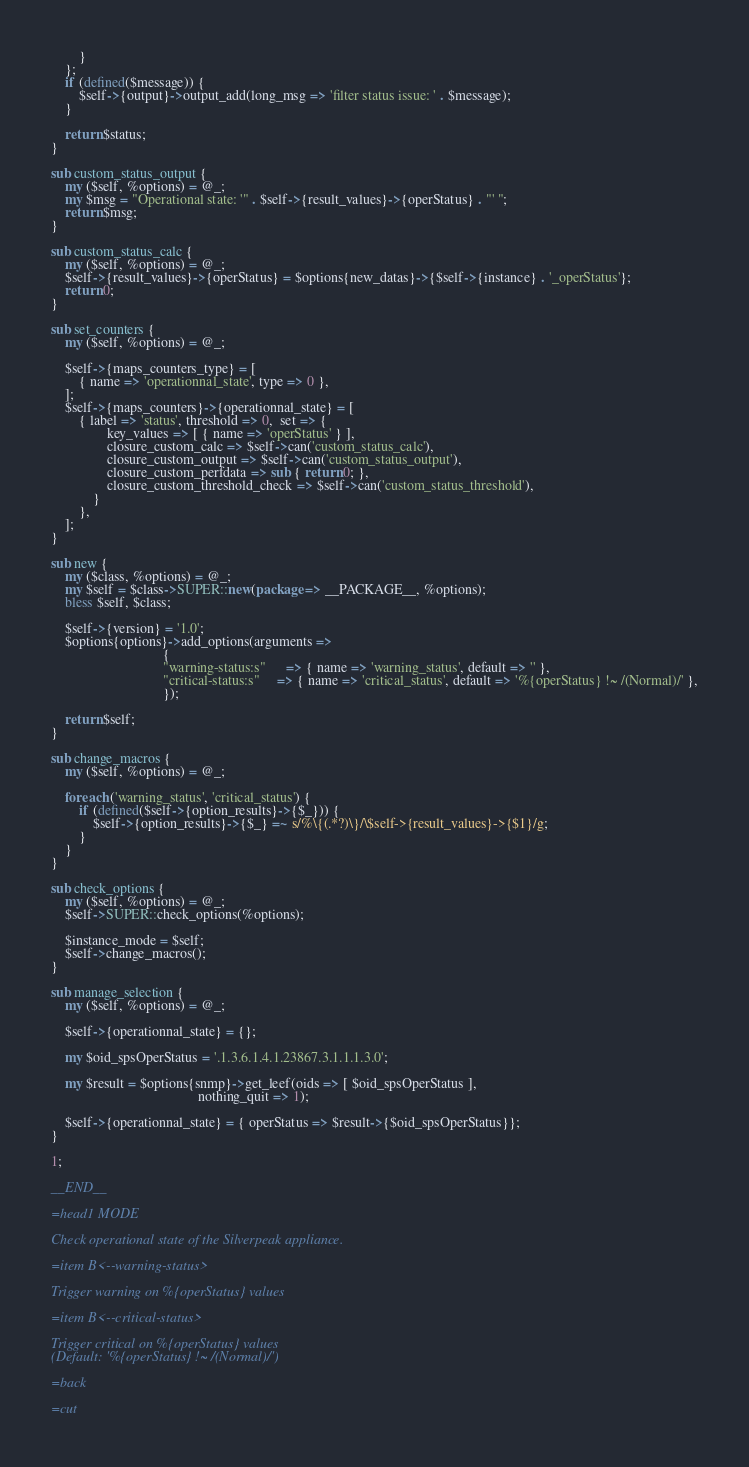<code> <loc_0><loc_0><loc_500><loc_500><_Perl_>        }
    };
    if (defined($message)) {
        $self->{output}->output_add(long_msg => 'filter status issue: ' . $message);
    }

    return $status;
}

sub custom_status_output {
    my ($self, %options) = @_;
    my $msg = "Operational state: '" . $self->{result_values}->{operStatus} . "' ";
    return $msg;
}

sub custom_status_calc {
    my ($self, %options) = @_;
    $self->{result_values}->{operStatus} = $options{new_datas}->{$self->{instance} . '_operStatus'};
    return 0;
}

sub set_counters {
    my ($self, %options) = @_;

    $self->{maps_counters_type} = [
        { name => 'operationnal_state', type => 0 },
    ];
    $self->{maps_counters}->{operationnal_state} = [
        { label => 'status', threshold => 0,  set => {
                key_values => [ { name => 'operStatus' } ],
                closure_custom_calc => $self->can('custom_status_calc'),
                closure_custom_output => $self->can('custom_status_output'),
                closure_custom_perfdata => sub { return 0; },
                closure_custom_threshold_check => $self->can('custom_status_threshold'),
            }
        },
    ];
}

sub new {
    my ($class, %options) = @_;
    my $self = $class->SUPER::new(package => __PACKAGE__, %options);
    bless $self, $class;

    $self->{version} = '1.0';
    $options{options}->add_options(arguments =>
                                {
                                "warning-status:s"      => { name => 'warning_status', default => '' },
                                "critical-status:s"     => { name => 'critical_status', default => '%{operStatus} !~ /(Normal)/' },
                                });

    return $self;
}

sub change_macros {
    my ($self, %options) = @_;

    foreach ('warning_status', 'critical_status') {
        if (defined($self->{option_results}->{$_})) {
            $self->{option_results}->{$_} =~ s/%\{(.*?)\}/\$self->{result_values}->{$1}/g;
        }
    }
}

sub check_options {
    my ($self, %options) = @_;
    $self->SUPER::check_options(%options);

    $instance_mode = $self;
    $self->change_macros();
}

sub manage_selection {
    my ($self, %options) = @_;

    $self->{operationnal_state} = {};

    my $oid_spsOperStatus = '.1.3.6.1.4.1.23867.3.1.1.1.3.0';

    my $result = $options{snmp}->get_leef(oids => [ $oid_spsOperStatus ],
                                          nothing_quit => 1);

    $self->{operationnal_state} = { operStatus => $result->{$oid_spsOperStatus}};
}

1;

__END__

=head1 MODE

Check operational state of the Silverpeak appliance.

=item B<--warning-status>

Trigger warning on %{operStatus} values

=item B<--critical-status>

Trigger critical on %{operStatus} values
(Default: '%{operStatus} !~ /(Normal)/')

=back

=cut
</code> 